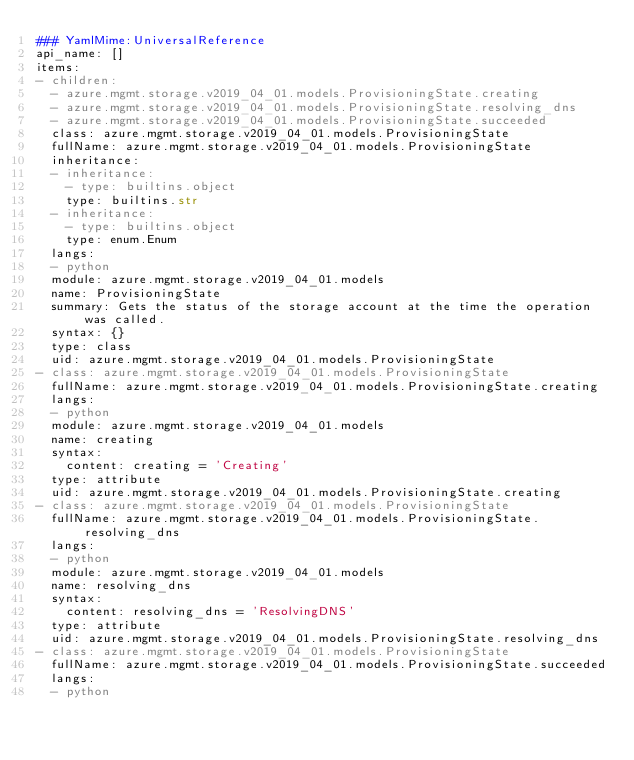Convert code to text. <code><loc_0><loc_0><loc_500><loc_500><_YAML_>### YamlMime:UniversalReference
api_name: []
items:
- children:
  - azure.mgmt.storage.v2019_04_01.models.ProvisioningState.creating
  - azure.mgmt.storage.v2019_04_01.models.ProvisioningState.resolving_dns
  - azure.mgmt.storage.v2019_04_01.models.ProvisioningState.succeeded
  class: azure.mgmt.storage.v2019_04_01.models.ProvisioningState
  fullName: azure.mgmt.storage.v2019_04_01.models.ProvisioningState
  inheritance:
  - inheritance:
    - type: builtins.object
    type: builtins.str
  - inheritance:
    - type: builtins.object
    type: enum.Enum
  langs:
  - python
  module: azure.mgmt.storage.v2019_04_01.models
  name: ProvisioningState
  summary: Gets the status of the storage account at the time the operation was called.
  syntax: {}
  type: class
  uid: azure.mgmt.storage.v2019_04_01.models.ProvisioningState
- class: azure.mgmt.storage.v2019_04_01.models.ProvisioningState
  fullName: azure.mgmt.storage.v2019_04_01.models.ProvisioningState.creating
  langs:
  - python
  module: azure.mgmt.storage.v2019_04_01.models
  name: creating
  syntax:
    content: creating = 'Creating'
  type: attribute
  uid: azure.mgmt.storage.v2019_04_01.models.ProvisioningState.creating
- class: azure.mgmt.storage.v2019_04_01.models.ProvisioningState
  fullName: azure.mgmt.storage.v2019_04_01.models.ProvisioningState.resolving_dns
  langs:
  - python
  module: azure.mgmt.storage.v2019_04_01.models
  name: resolving_dns
  syntax:
    content: resolving_dns = 'ResolvingDNS'
  type: attribute
  uid: azure.mgmt.storage.v2019_04_01.models.ProvisioningState.resolving_dns
- class: azure.mgmt.storage.v2019_04_01.models.ProvisioningState
  fullName: azure.mgmt.storage.v2019_04_01.models.ProvisioningState.succeeded
  langs:
  - python</code> 